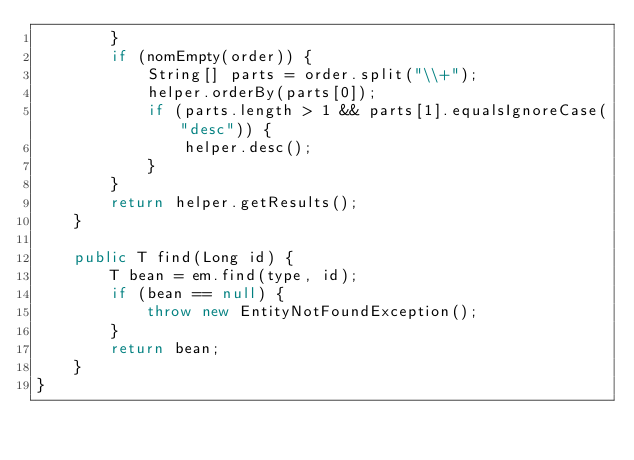<code> <loc_0><loc_0><loc_500><loc_500><_Java_>        }
        if (nomEmpty(order)) {
            String[] parts = order.split("\\+");
            helper.orderBy(parts[0]);
            if (parts.length > 1 && parts[1].equalsIgnoreCase("desc")) {
                helper.desc();
            }
        }
        return helper.getResults();
    }

    public T find(Long id) {
        T bean = em.find(type, id);
        if (bean == null) {
            throw new EntityNotFoundException();
        }
        return bean;
    }
}</code> 